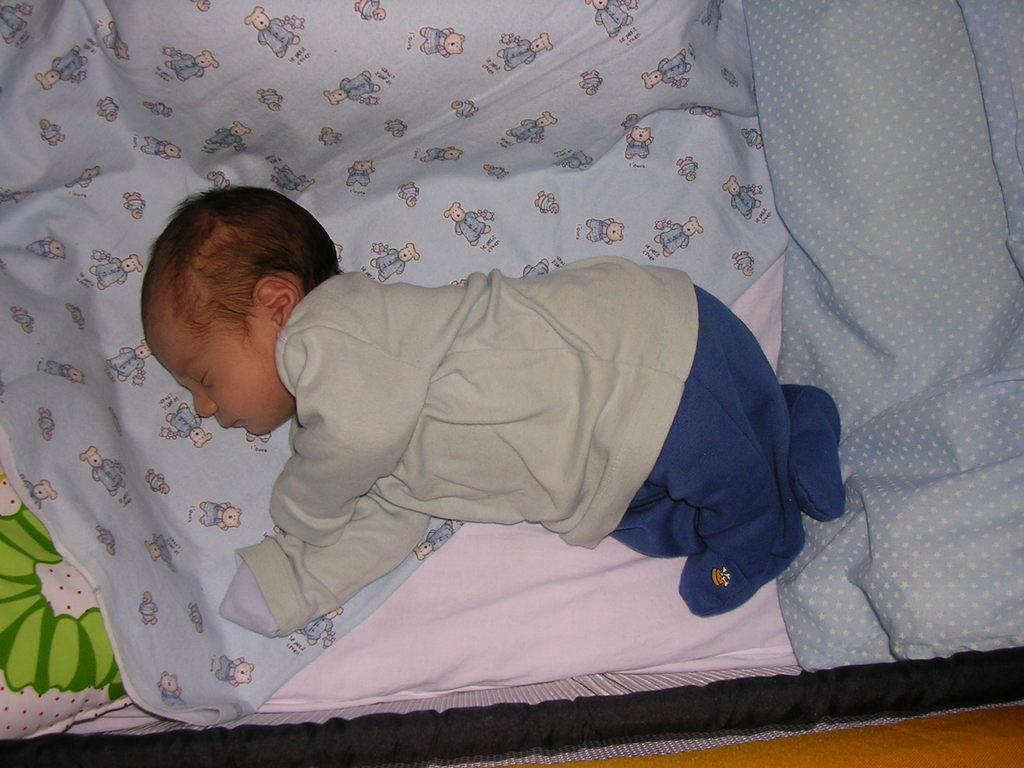What is the main subject of the image? There is a baby in the image. Where is the baby located? The baby is laying on a bed sheet. What can be seen on the bed sheet? There are cartoon images on the bed sheet. How does the baby play with the end of the bed sheet in the image? There is no indication in the image that the baby is playing with the end of the bed sheet, nor is there any visible "end" of the bed sheet. 